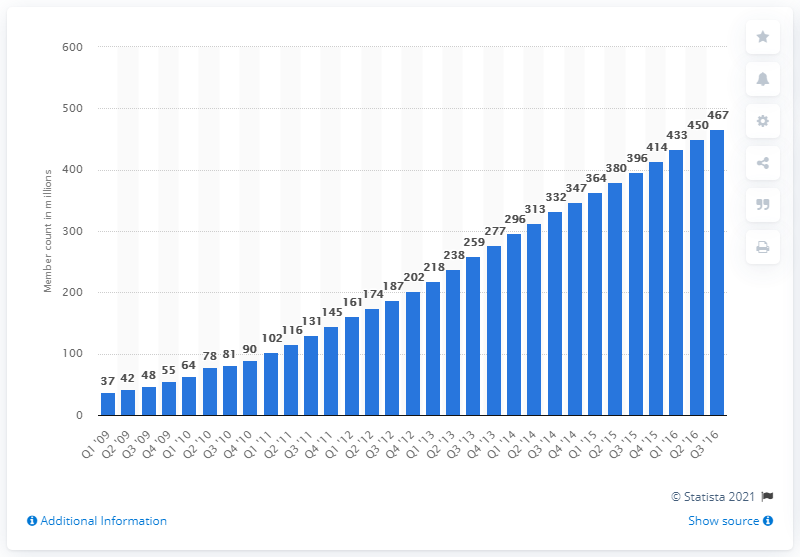Indicate a few pertinent items in this graphic. In the previous quarter, LinkedIn had 450 members. In the most recent quarter, LinkedIn had a total of 467 members. 